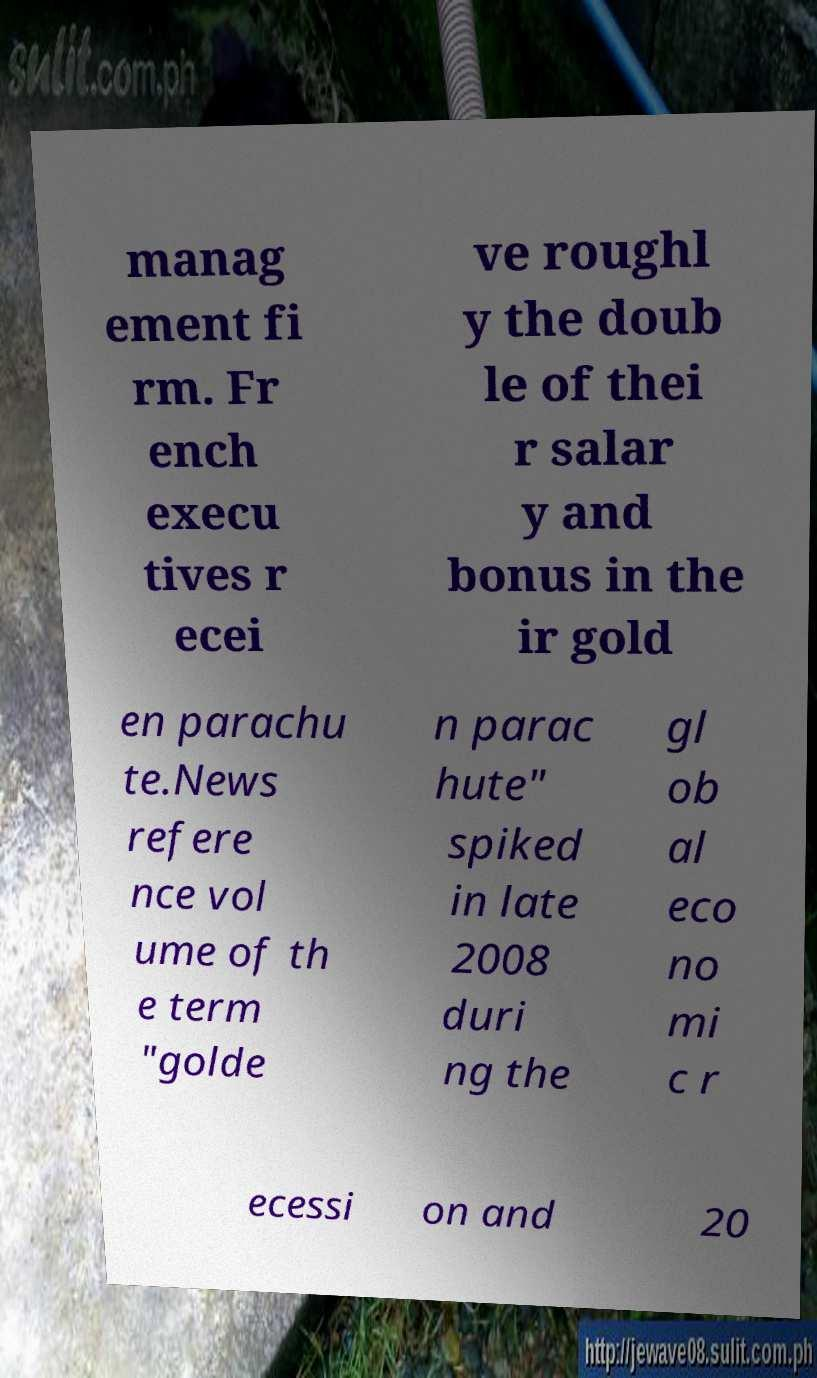I need the written content from this picture converted into text. Can you do that? manag ement fi rm. Fr ench execu tives r ecei ve roughl y the doub le of thei r salar y and bonus in the ir gold en parachu te.News refere nce vol ume of th e term "golde n parac hute" spiked in late 2008 duri ng the gl ob al eco no mi c r ecessi on and 20 